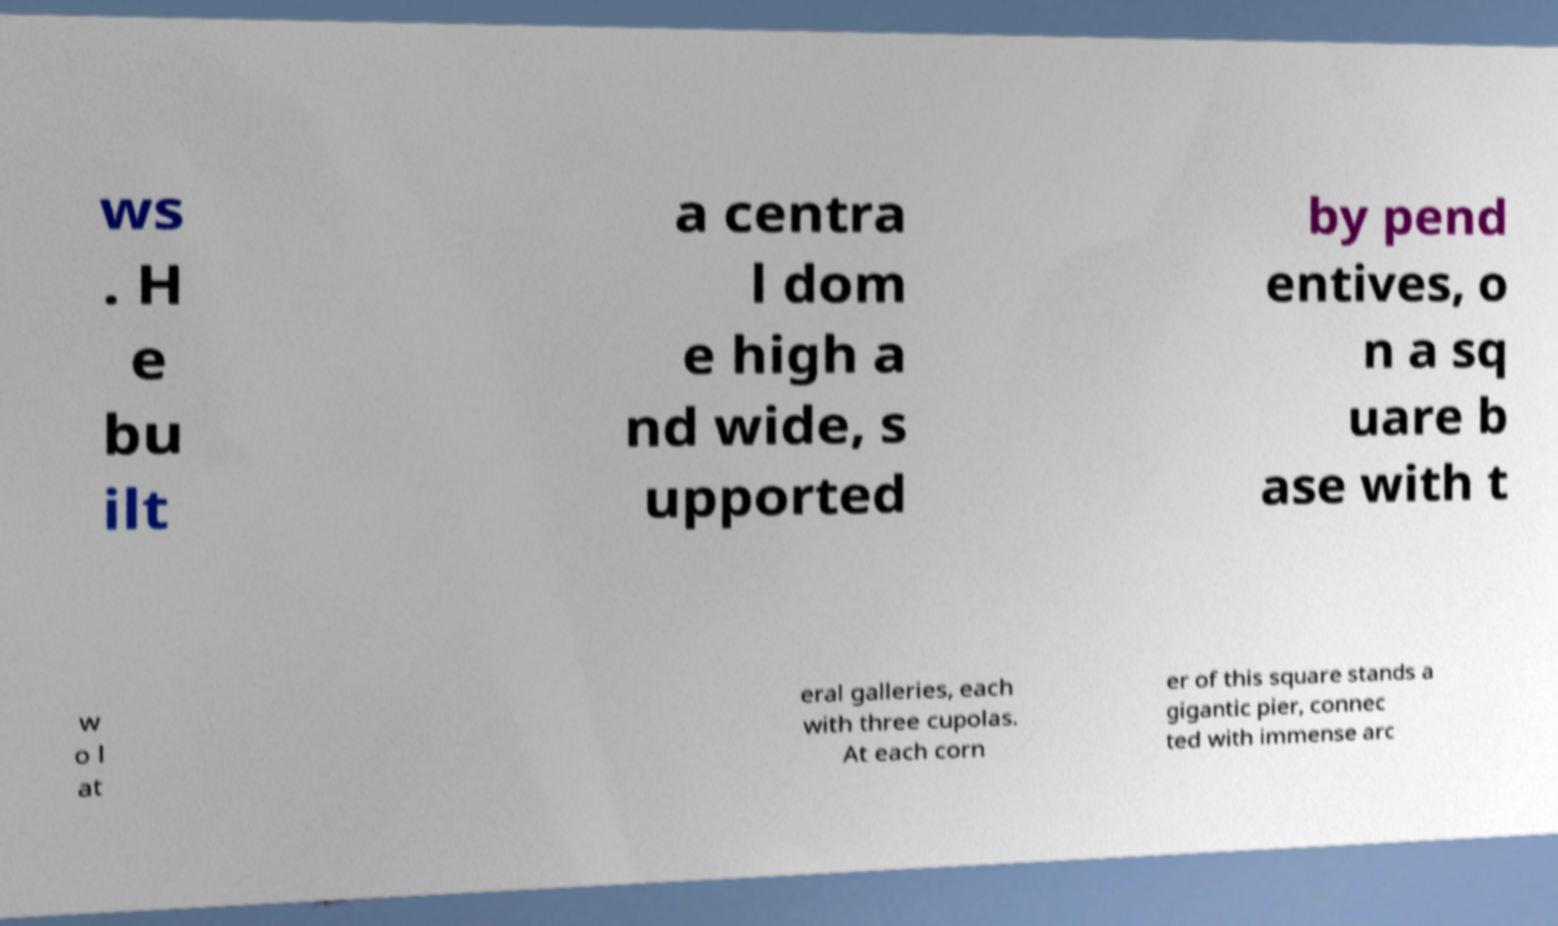I need the written content from this picture converted into text. Can you do that? ws . H e bu ilt a centra l dom e high a nd wide, s upported by pend entives, o n a sq uare b ase with t w o l at eral galleries, each with three cupolas. At each corn er of this square stands a gigantic pier, connec ted with immense arc 